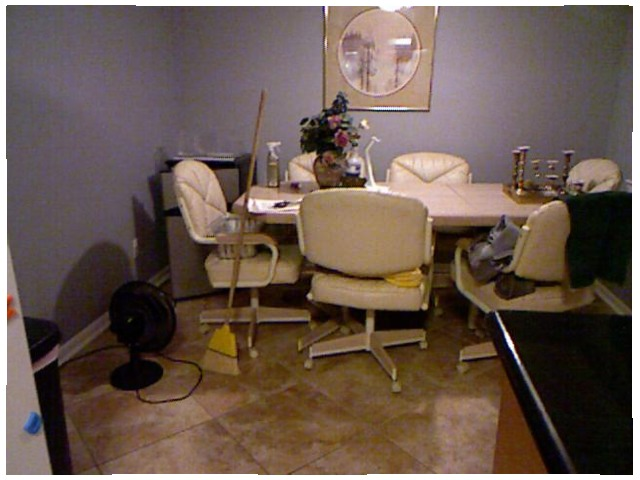<image>
Can you confirm if the chair is under the table? Yes. The chair is positioned underneath the table, with the table above it in the vertical space. Is the broom on the chair? Yes. Looking at the image, I can see the broom is positioned on top of the chair, with the chair providing support. Is there a fan on the floor? Yes. Looking at the image, I can see the fan is positioned on top of the floor, with the floor providing support. Is there a chair on the table? No. The chair is not positioned on the table. They may be near each other, but the chair is not supported by or resting on top of the table. Is the broom stick next to the chair? No. The broom stick is not positioned next to the chair. They are located in different areas of the scene. 